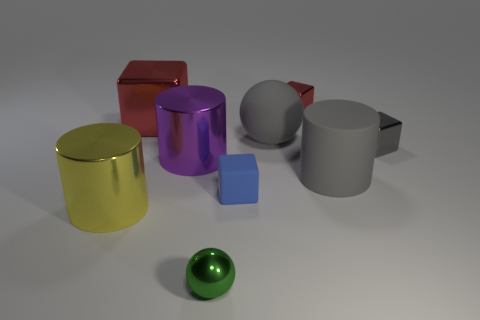What number of other things are made of the same material as the small green object?
Keep it short and to the point. 5. What number of objects are either things behind the small green sphere or blocks in front of the gray metallic object?
Provide a succinct answer. 8. Does the large rubber object that is in front of the purple shiny cylinder have the same shape as the red thing that is right of the small green metal ball?
Offer a very short reply. No. There is a blue thing that is the same size as the green object; what is its shape?
Provide a succinct answer. Cube. How many metallic things are big purple balls or small blue objects?
Offer a very short reply. 0. Is the material of the cylinder right of the tiny ball the same as the tiny gray block in front of the big red cube?
Give a very brief answer. No. There is a small sphere that is the same material as the big red thing; what color is it?
Ensure brevity in your answer.  Green. Are there more tiny blue matte cubes that are to the left of the tiny green shiny sphere than large metallic blocks that are to the left of the tiny blue block?
Give a very brief answer. No. Are there any big purple objects?
Keep it short and to the point. Yes. What is the material of the tiny thing that is the same color as the rubber cylinder?
Give a very brief answer. Metal. 